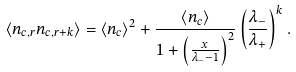Convert formula to latex. <formula><loc_0><loc_0><loc_500><loc_500>\langle n _ { c , r } n _ { c , r + k } \rangle = \langle n _ { c } \rangle ^ { 2 } + \frac { \langle n _ { c } \rangle } { 1 + \left ( \frac { x } { \lambda _ { - } - 1 } \right ) ^ { 2 } } \left ( \frac { \lambda _ { - } } { \lambda _ { + } } \right ) ^ { k } .</formula> 